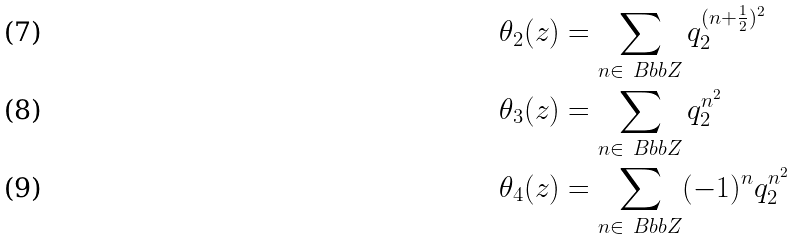<formula> <loc_0><loc_0><loc_500><loc_500>\theta _ { 2 } ( z ) & = \sum _ { n \in { \ B b b Z } } q _ { 2 } ^ { ( n + \frac { 1 } { 2 } ) ^ { 2 } } \\ \theta _ { 3 } ( z ) & = \sum _ { n \in { \ B b b Z } } q _ { 2 } ^ { n ^ { 2 } } \\ \theta _ { 4 } ( z ) & = \sum _ { n \in { \ B b b Z } } ( - 1 ) ^ { n } q _ { 2 } ^ { n ^ { 2 } }</formula> 